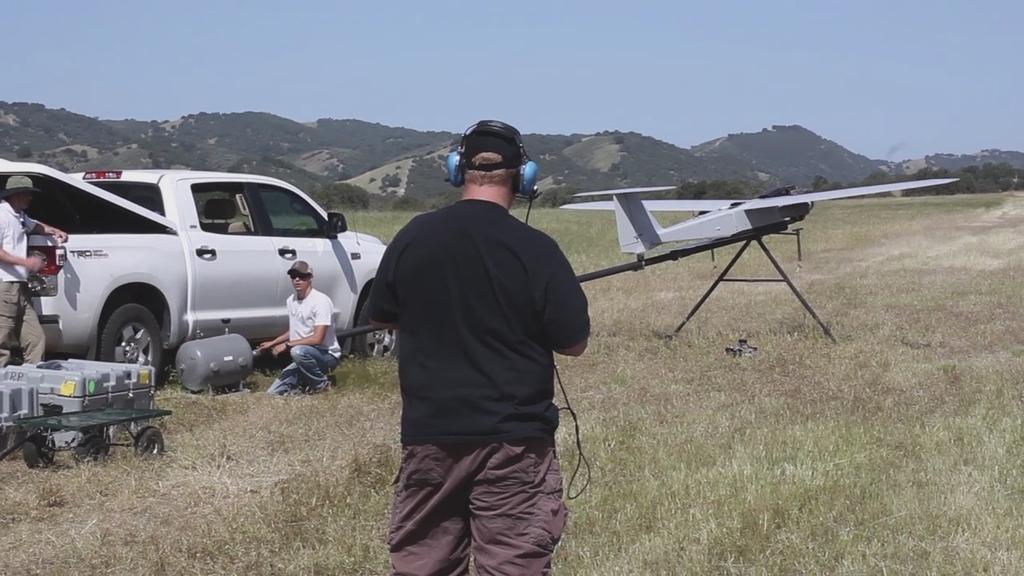Describe this image in one or two sentences. In this image in the front there is a person. In the background there is a car and there are persons standing and sitting and there is dry grass on the ground and there are mountains and there is an airplane model and there are objects which are grey in colour. 